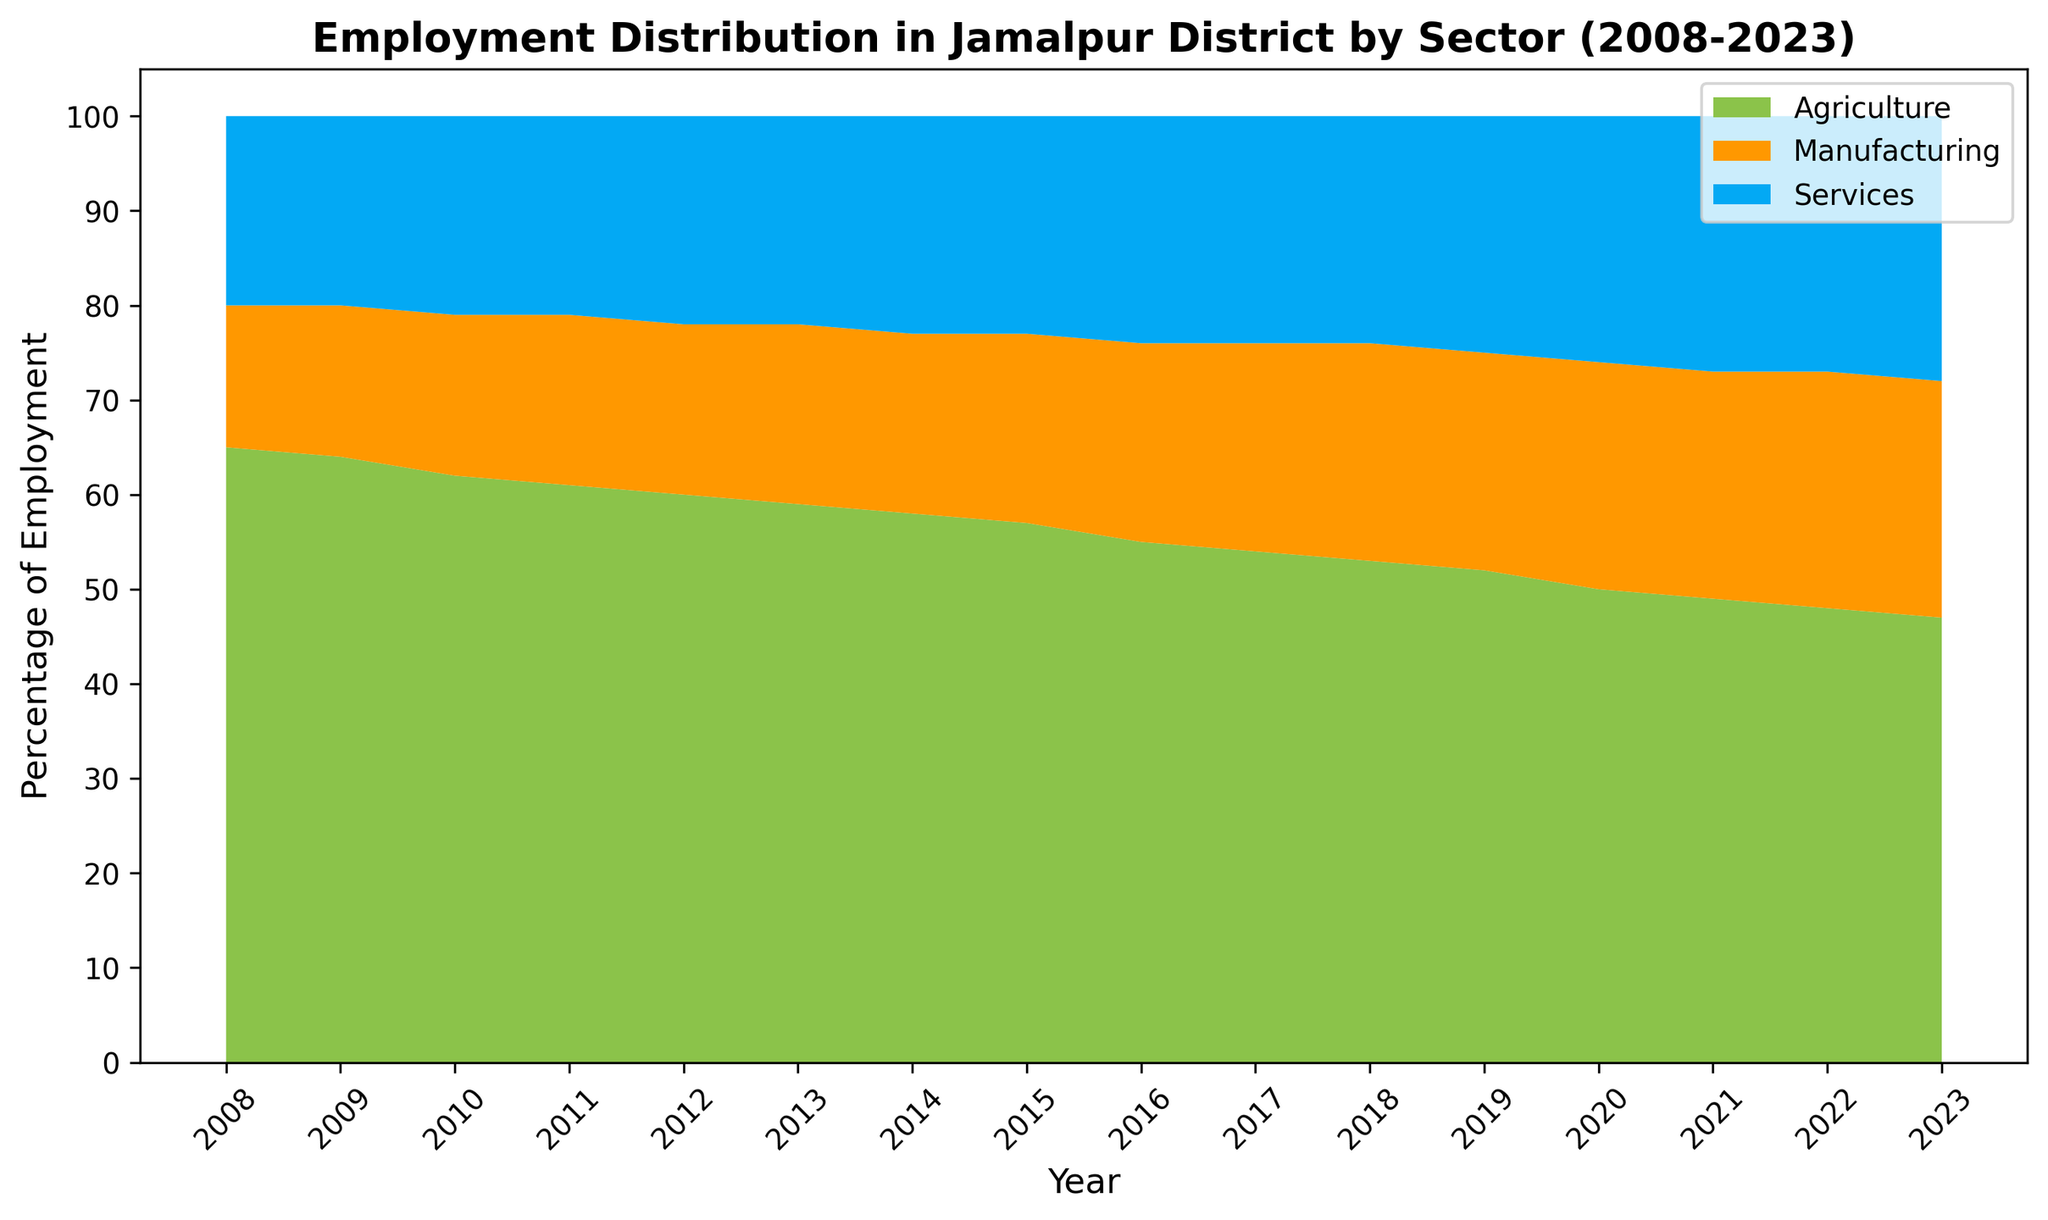What is the overall trend in employment in the agricultural sector over the past 15 years? Employment in the agricultural sector has been decreasing gradually over the past 15 years. This can be observed by the shrinking green area associated with agriculture from 2008 to 2023.
Answer: Decreasing How much did employment in the services sector increase from 2008 to 2023? Employment in the services sector increased from 20% in 2008 to 28% in 2023. The increase is calculated as 28 - 20 = 8%.
Answer: 8% Which sector had the highest employment in 2015? The agricultural sector had the highest employment in 2015, as evidenced by the largest green area for that year.
Answer: Agriculture Compare the employment distribution between agriculture and manufacturing in 2020. In 2020, agriculture had 50% employment, while manufacturing had 24%. The green area for agriculture is larger than the orange area for manufacturing, confirming the numerical values.
Answer: Agriculture > Manufacturing By how many percentage points did employment in manufacturing increase from 2008 to 2023? Employment in manufacturing increased from 15% in 2008 to 25% in 2023. The increase is calculated as 25 - 15 = 10 percentage points.
Answer: 10 What is the average percentage of employment in the services sector from 2008 to 2023? The average percentage of employment in the services sector is calculated by summing the yearly values and dividing by the number of years: (20 + 20 + 21 + 21 + 22 + 22 + 23 + 23 + 24 + 24 + 24 + 25 + 26 + 27 + 27 + 28) / 16 = 23.125%.
Answer: 23.125 Which sector showed the most significant decline in employment over the given period? The agricultural sector showed the most significant decline in employment from 65% in 2008 to 47% in 2023. The green area shrunk the most compared to the others, indicating a significant decline.
Answer: Agriculture In which year did the services sector first exceed 25% employment? The services sector first exceeded 25% employment in 2020, as the blue area reaches above the 25% mark in that year.
Answer: 2020 